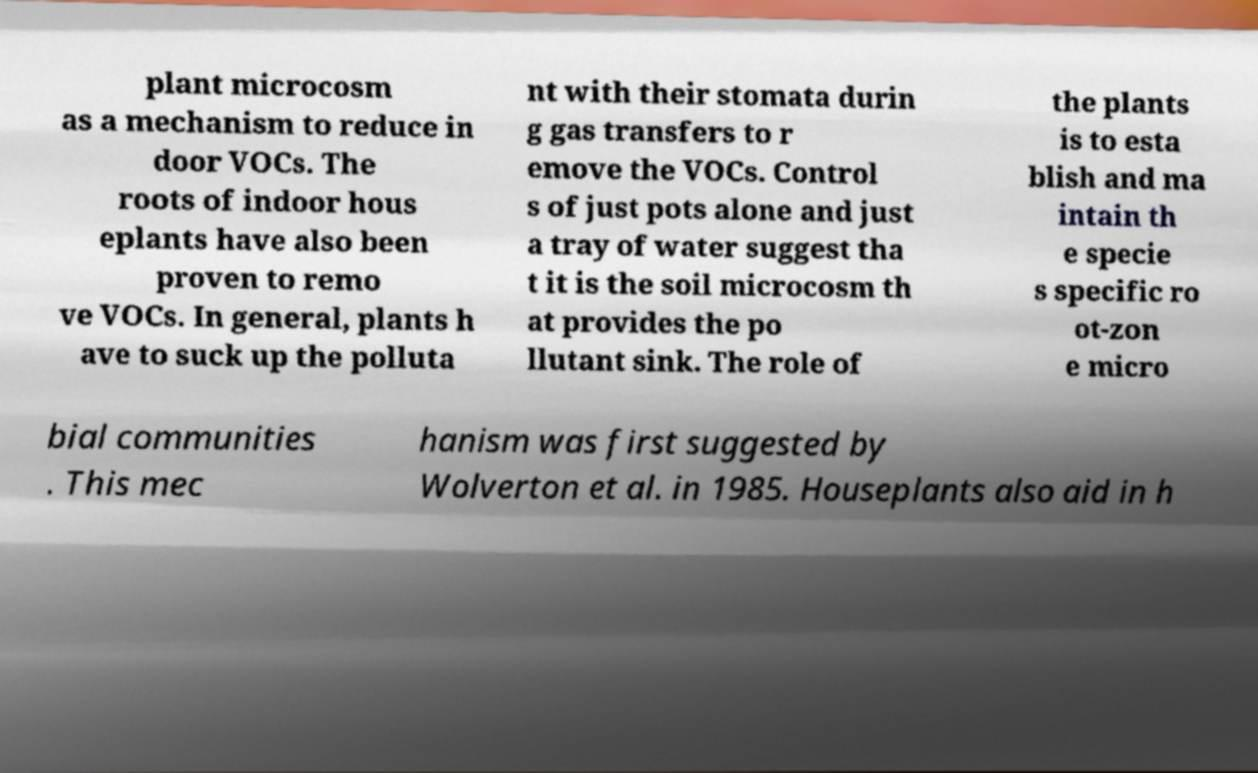I need the written content from this picture converted into text. Can you do that? plant microcosm as a mechanism to reduce in door VOCs. The roots of indoor hous eplants have also been proven to remo ve VOCs. In general, plants h ave to suck up the polluta nt with their stomata durin g gas transfers to r emove the VOCs. Control s of just pots alone and just a tray of water suggest tha t it is the soil microcosm th at provides the po llutant sink. The role of the plants is to esta blish and ma intain th e specie s specific ro ot-zon e micro bial communities . This mec hanism was first suggested by Wolverton et al. in 1985. Houseplants also aid in h 